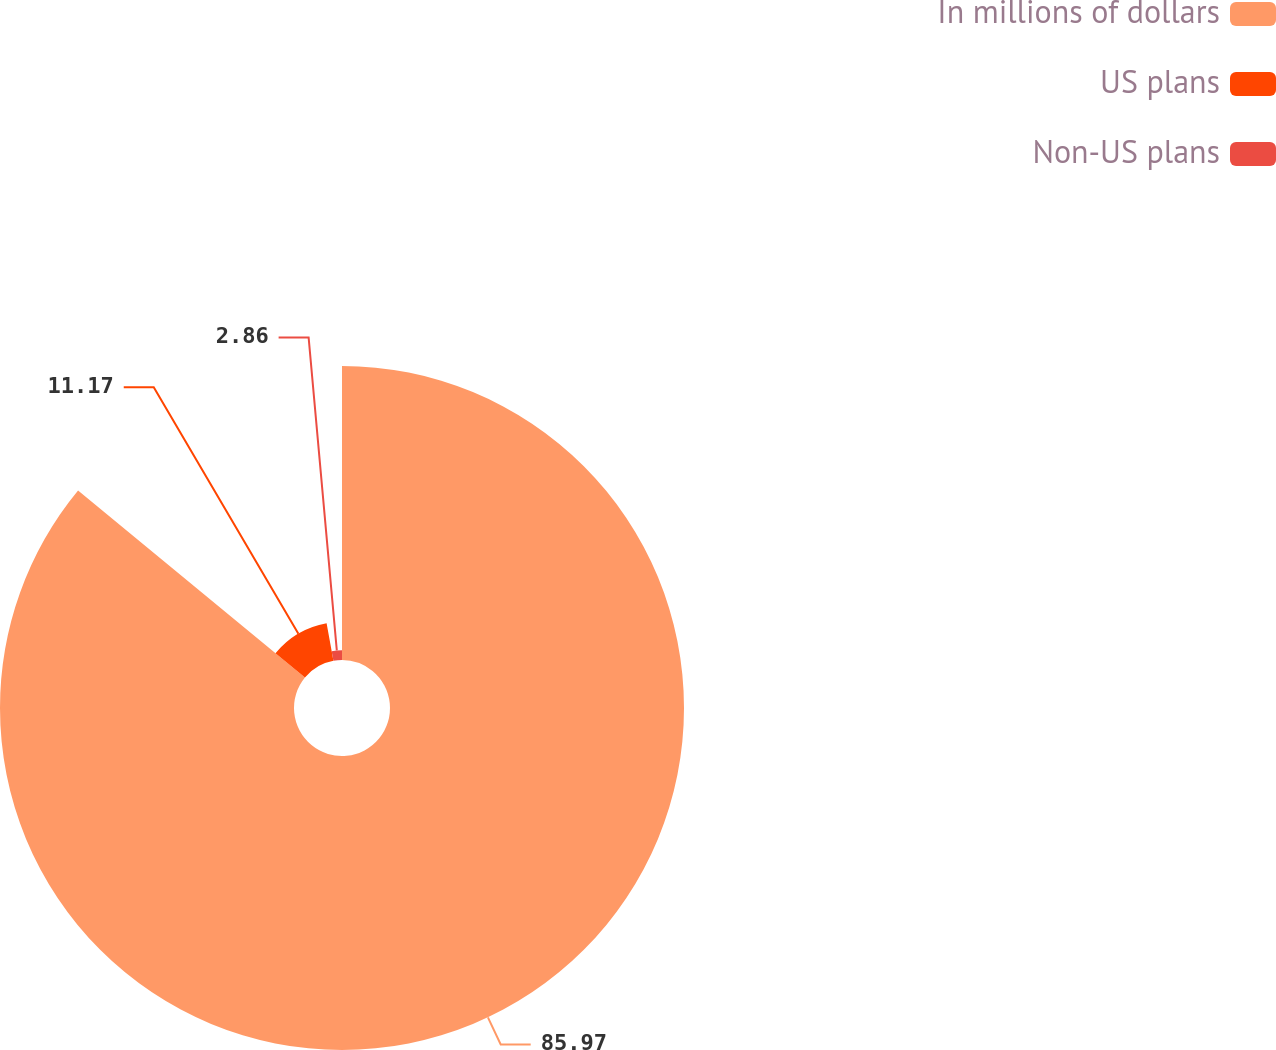Convert chart. <chart><loc_0><loc_0><loc_500><loc_500><pie_chart><fcel>In millions of dollars<fcel>US plans<fcel>Non-US plans<nl><fcel>85.97%<fcel>11.17%<fcel>2.86%<nl></chart> 